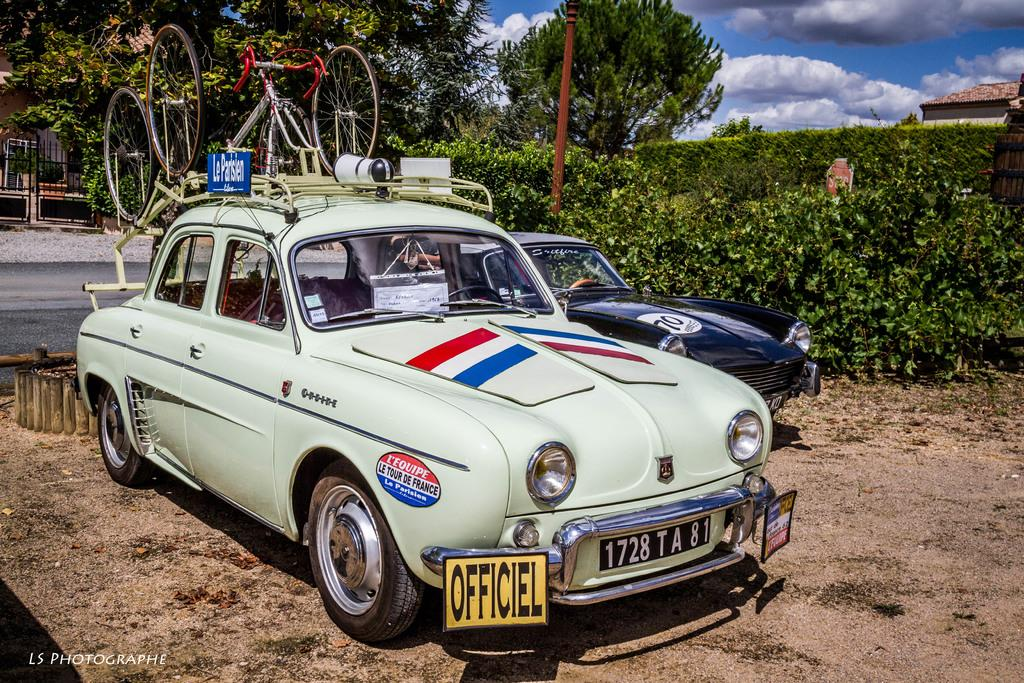What type of vehicles can be seen on the surface in the image? There are cars on the surface in the image. What is attached to one of the cars? There is a cart on one of the cars. What type of vegetation is visible in the image? There are plants visible in the image. What structure can be seen in the image? There is a pole in the image. What can be seen in the background of the image? There are trees, a roof top, and a gate visible in the background. What is the condition of the sky in the image? The sky is cloudy in the image. What type of meat is being grilled on the pole in the image? There is no meat present in the image, nor is there any indication of grilling or cooking. 